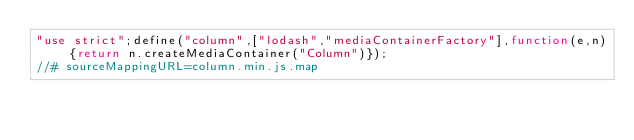Convert code to text. <code><loc_0><loc_0><loc_500><loc_500><_JavaScript_>"use strict";define("column",["lodash","mediaContainerFactory"],function(e,n){return n.createMediaContainer("Column")});
//# sourceMappingURL=column.min.js.map</code> 